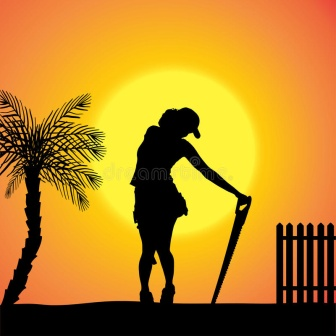If the silhouette were to come to life, what might it say about the day's work? If the silhouette were to come to life, it might say, 'Today was a day of progress and patience, each shovel of earth bringing us closer to the bounty we seek. The sun’s descent reminds me of the endless cycles of nature, where effort meets reward. As I stand here, feeling the last warmth of the day, I know that tomorrow will bring another opportunity to nurture the land and support the life it gives. There's a profound satisfaction in knowing that with each sunset, we move closer to our goals.' 